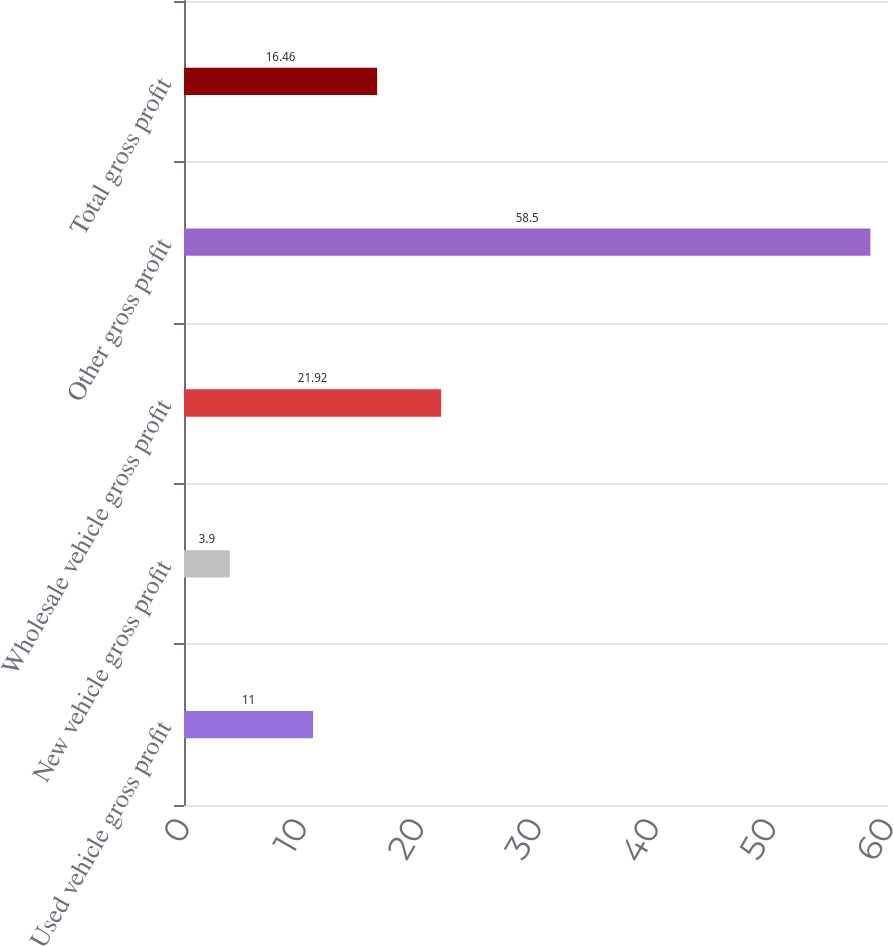Convert chart to OTSL. <chart><loc_0><loc_0><loc_500><loc_500><bar_chart><fcel>Used vehicle gross profit<fcel>New vehicle gross profit<fcel>Wholesale vehicle gross profit<fcel>Other gross profit<fcel>Total gross profit<nl><fcel>11<fcel>3.9<fcel>21.92<fcel>58.5<fcel>16.46<nl></chart> 